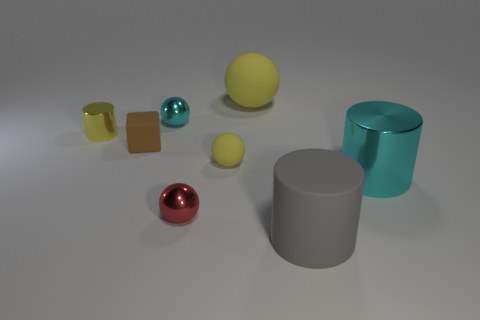Add 1 matte cylinders. How many objects exist? 9 Subtract all tiny cyan metallic spheres. How many spheres are left? 3 Subtract all yellow cylinders. How many cylinders are left? 2 Subtract 1 cylinders. How many cylinders are left? 2 Subtract all yellow cylinders. How many red spheres are left? 1 Subtract all blue cubes. Subtract all cyan balls. How many cubes are left? 1 Subtract all tiny green cylinders. Subtract all tiny red balls. How many objects are left? 7 Add 7 cyan shiny cylinders. How many cyan shiny cylinders are left? 8 Add 8 green balls. How many green balls exist? 8 Subtract 1 brown cubes. How many objects are left? 7 